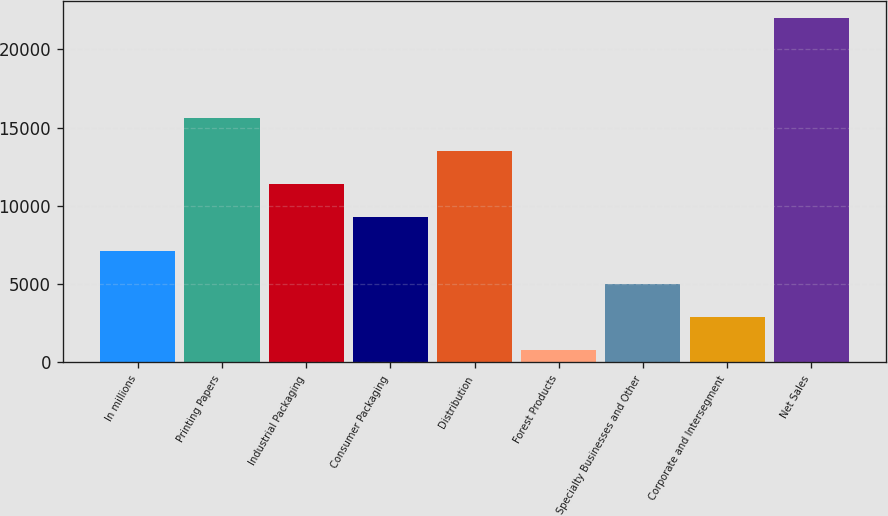Convert chart. <chart><loc_0><loc_0><loc_500><loc_500><bar_chart><fcel>In millions<fcel>Printing Papers<fcel>Industrial Packaging<fcel>Consumer Packaging<fcel>Distribution<fcel>Forest Products<fcel>Specialty Businesses and Other<fcel>Corporate and Intersegment<fcel>Net Sales<nl><fcel>7134<fcel>15626<fcel>11380<fcel>9257<fcel>13503<fcel>765<fcel>5011<fcel>2888<fcel>21995<nl></chart> 